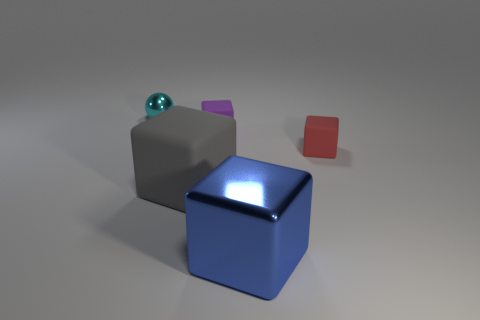There is a small rubber block that is to the right of the large shiny block; how many blue blocks are in front of it?
Provide a short and direct response. 1. What material is the gray object that is the same shape as the red rubber object?
Your response must be concise. Rubber. Do the metallic object that is on the right side of the small cyan ball and the small metallic sphere have the same color?
Keep it short and to the point. No. Is the small cyan thing made of the same material as the big thing that is to the right of the gray object?
Offer a terse response. Yes. There is a big thing left of the tiny purple matte thing; what shape is it?
Offer a terse response. Cube. What number of other things are there of the same material as the small purple object
Your response must be concise. 2. The metal sphere has what size?
Keep it short and to the point. Small. How many other objects are there of the same color as the tiny metallic sphere?
Provide a succinct answer. 0. What color is the object that is to the left of the tiny purple block and to the right of the tiny cyan ball?
Ensure brevity in your answer.  Gray. What number of gray blocks are there?
Your answer should be very brief. 1. 